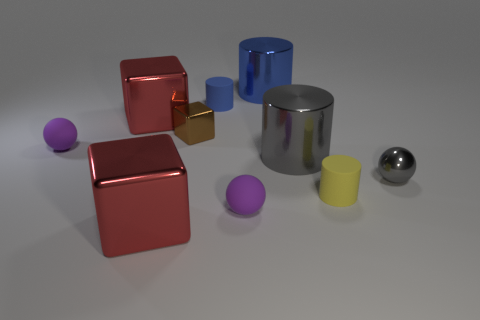There is a cylinder that is the same color as the tiny metallic sphere; what material is it?
Your response must be concise. Metal. There is a small matte cylinder that is behind the yellow matte thing; is it the same color as the tiny rubber ball that is right of the tiny blue object?
Provide a short and direct response. No. Are there more purple matte things that are behind the tiny yellow object than blue shiny cylinders on the right side of the brown metallic cube?
Offer a terse response. No. There is another tiny object that is the same shape as the tiny blue matte thing; what is its color?
Offer a terse response. Yellow. Is there anything else that has the same shape as the big blue thing?
Ensure brevity in your answer.  Yes. There is a tiny brown thing; does it have the same shape as the red shiny object that is in front of the large gray cylinder?
Offer a very short reply. Yes. What number of other things are the same material as the yellow cylinder?
Your answer should be compact. 3. Do the small metallic sphere and the metallic cylinder in front of the small block have the same color?
Offer a very short reply. Yes. What is the purple sphere that is behind the gray shiny cylinder made of?
Your answer should be compact. Rubber. Are there any cylinders that have the same color as the small metal sphere?
Ensure brevity in your answer.  Yes. 